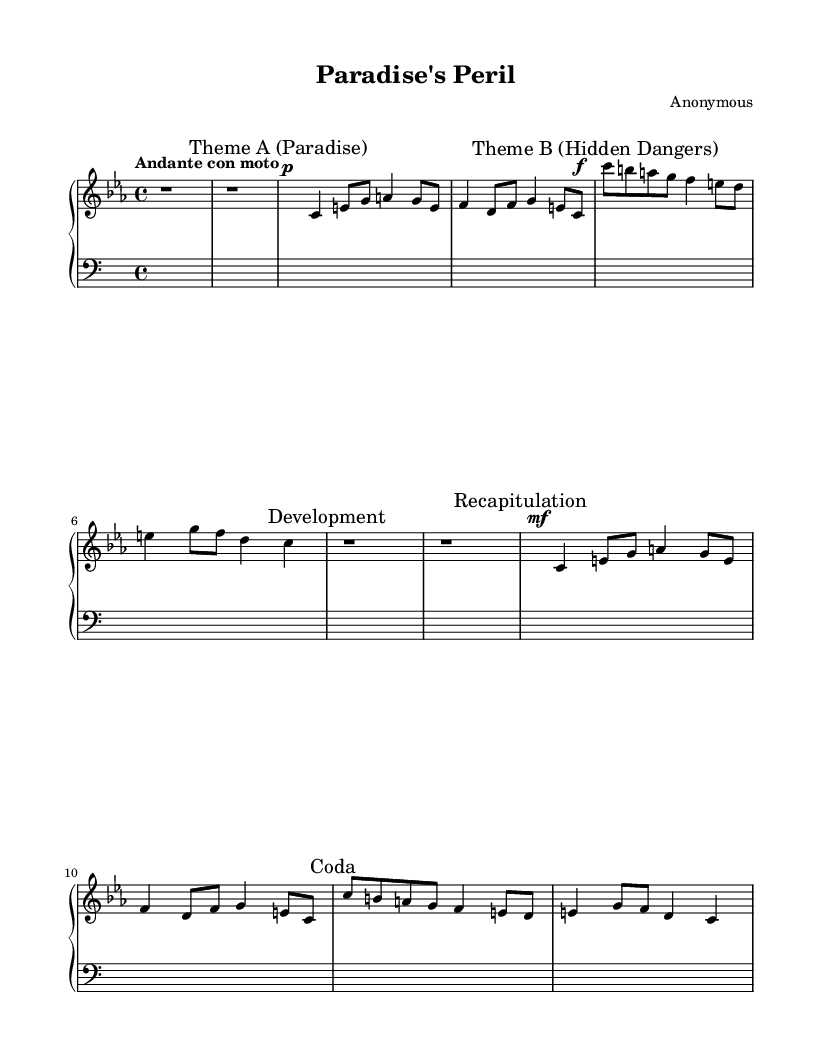What is the key signature of this music? The key signature indicated in the music is C minor, which has three flats.
Answer: C minor What is the time signature of this music? The time signature is shown at the beginning of the piece, which is 4/4, meaning there are four beats per measure.
Answer: 4/4 What is the tempo marking for this piece? The tempo marking written in Italian above the music indicates the speed, which is "Andante con moto," suggesting a moderately slow tempo with some motion.
Answer: Andante con moto How many sections are identified in the piece? The music explicitly marks three main sections: Theme A, Theme B, and a recapitulatory section, indicating a tripartite structure.
Answer: Three What dynamic level is used at the beginning of Theme A? The dynamic marking for Theme A specifies a piano (soft) dynamic, indicated with the symbol 'p' at the beginning of the section.
Answer: Piano Which theme represents "Hidden Dangers"? The music marks Theme B specifically as "Hidden Dangers," with the notation beginning at that point in the score.
Answer: Theme B What is the final section labeled in the score? The final section of the composition is labeled as "Coda," which is often a concluding passage in the music.
Answer: Coda 